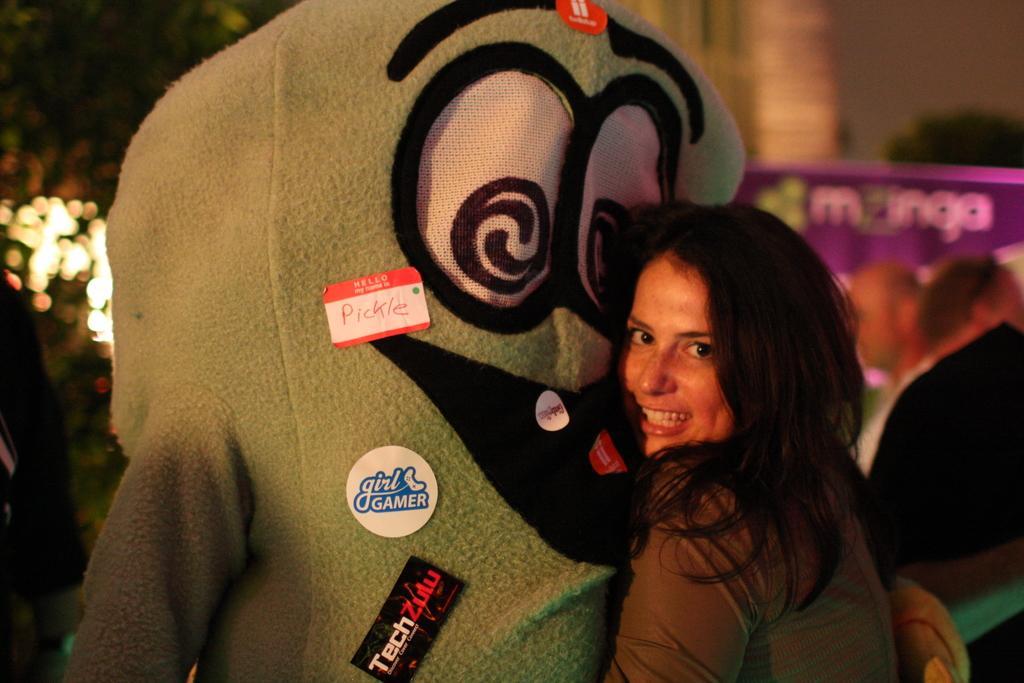How would you summarize this image in a sentence or two? In this image we can see there is a girl with a smile on her face is hugged by a teddy-bear. In the background there are trees and building. 